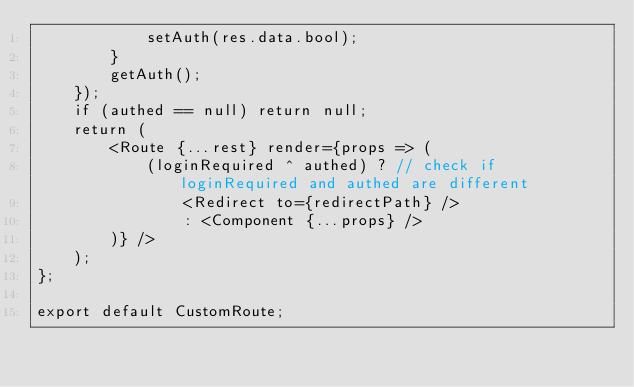<code> <loc_0><loc_0><loc_500><loc_500><_JavaScript_>            setAuth(res.data.bool);
        }
        getAuth();
    });
    if (authed == null) return null;
    return (
        <Route {...rest} render={props => (
            (loginRequired ^ authed) ? // check if loginRequired and authed are different
                <Redirect to={redirectPath} />
                : <Component {...props} />
        )} />
    );
};

export default CustomRoute;</code> 